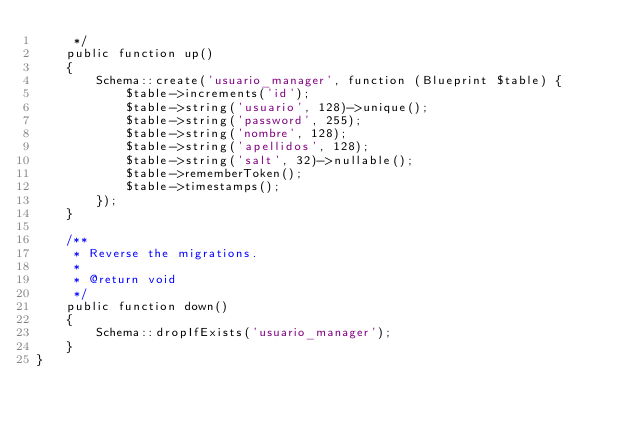Convert code to text. <code><loc_0><loc_0><loc_500><loc_500><_PHP_>     */
    public function up()
    {
        Schema::create('usuario_manager', function (Blueprint $table) {
            $table->increments('id');
            $table->string('usuario', 128)->unique();
            $table->string('password', 255);
            $table->string('nombre', 128);
            $table->string('apellidos', 128);
            $table->string('salt', 32)->nullable();
            $table->rememberToken();
            $table->timestamps();
        });
    }

    /**
     * Reverse the migrations.
     *
     * @return void
     */
    public function down()
    {
        Schema::dropIfExists('usuario_manager');
    }
}
</code> 